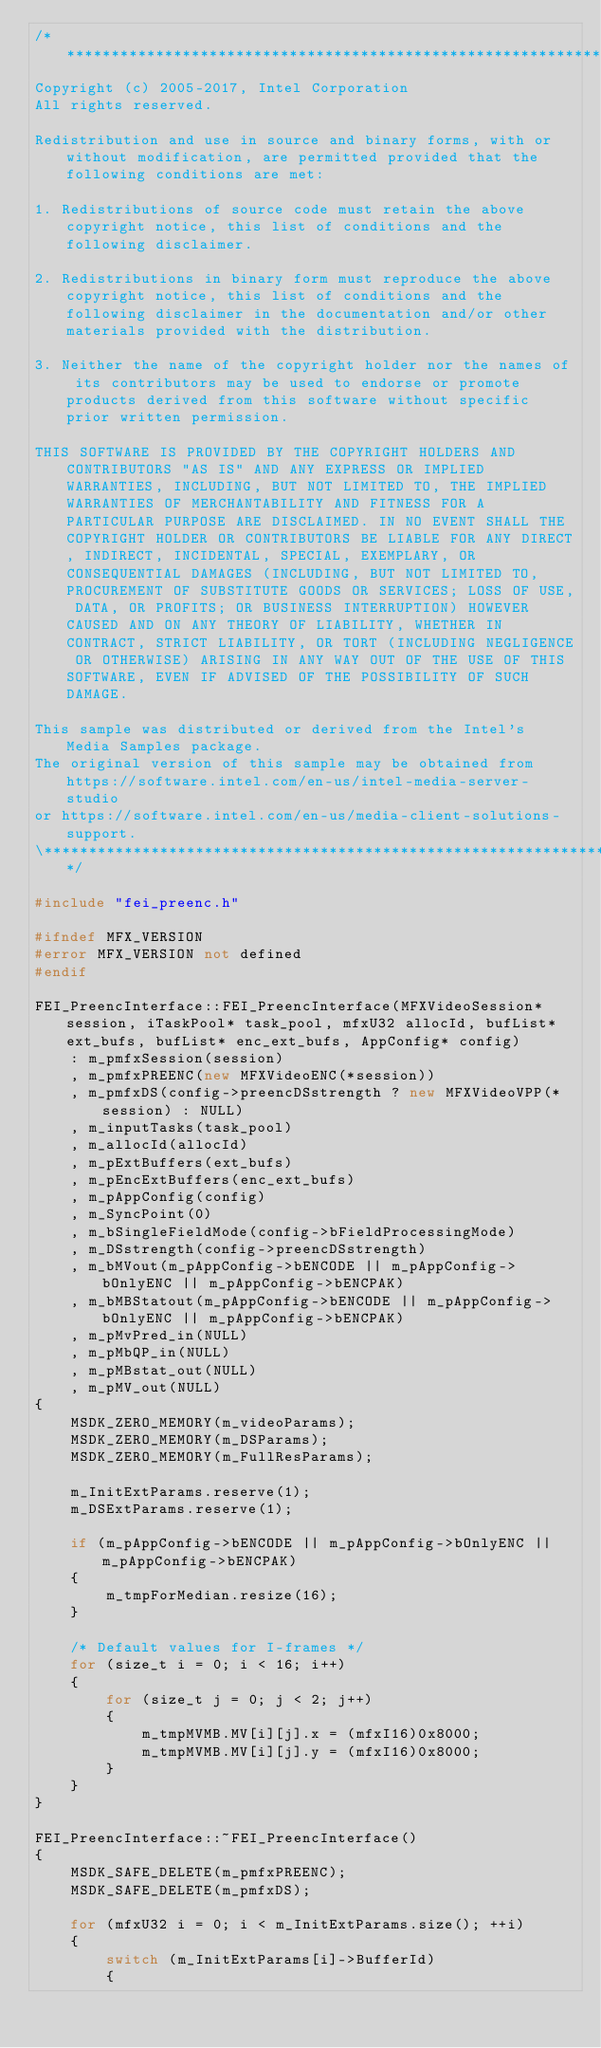<code> <loc_0><loc_0><loc_500><loc_500><_C++_>/******************************************************************************\
Copyright (c) 2005-2017, Intel Corporation
All rights reserved.

Redistribution and use in source and binary forms, with or without modification, are permitted provided that the following conditions are met:

1. Redistributions of source code must retain the above copyright notice, this list of conditions and the following disclaimer.

2. Redistributions in binary form must reproduce the above copyright notice, this list of conditions and the following disclaimer in the documentation and/or other materials provided with the distribution.

3. Neither the name of the copyright holder nor the names of its contributors may be used to endorse or promote products derived from this software without specific prior written permission.

THIS SOFTWARE IS PROVIDED BY THE COPYRIGHT HOLDERS AND CONTRIBUTORS "AS IS" AND ANY EXPRESS OR IMPLIED WARRANTIES, INCLUDING, BUT NOT LIMITED TO, THE IMPLIED WARRANTIES OF MERCHANTABILITY AND FITNESS FOR A PARTICULAR PURPOSE ARE DISCLAIMED. IN NO EVENT SHALL THE COPYRIGHT HOLDER OR CONTRIBUTORS BE LIABLE FOR ANY DIRECT, INDIRECT, INCIDENTAL, SPECIAL, EXEMPLARY, OR CONSEQUENTIAL DAMAGES (INCLUDING, BUT NOT LIMITED TO, PROCUREMENT OF SUBSTITUTE GOODS OR SERVICES; LOSS OF USE, DATA, OR PROFITS; OR BUSINESS INTERRUPTION) HOWEVER CAUSED AND ON ANY THEORY OF LIABILITY, WHETHER IN CONTRACT, STRICT LIABILITY, OR TORT (INCLUDING NEGLIGENCE OR OTHERWISE) ARISING IN ANY WAY OUT OF THE USE OF THIS SOFTWARE, EVEN IF ADVISED OF THE POSSIBILITY OF SUCH DAMAGE.

This sample was distributed or derived from the Intel's Media Samples package.
The original version of this sample may be obtained from https://software.intel.com/en-us/intel-media-server-studio
or https://software.intel.com/en-us/media-client-solutions-support.
\**********************************************************************************/

#include "fei_preenc.h"

#ifndef MFX_VERSION
#error MFX_VERSION not defined
#endif

FEI_PreencInterface::FEI_PreencInterface(MFXVideoSession* session, iTaskPool* task_pool, mfxU32 allocId, bufList* ext_bufs, bufList* enc_ext_bufs, AppConfig* config)
    : m_pmfxSession(session)
    , m_pmfxPREENC(new MFXVideoENC(*session))
    , m_pmfxDS(config->preencDSstrength ? new MFXVideoVPP(*session) : NULL)
    , m_inputTasks(task_pool)
    , m_allocId(allocId)
    , m_pExtBuffers(ext_bufs)
    , m_pEncExtBuffers(enc_ext_bufs)
    , m_pAppConfig(config)
    , m_SyncPoint(0)
    , m_bSingleFieldMode(config->bFieldProcessingMode)
    , m_DSstrength(config->preencDSstrength)
    , m_bMVout(m_pAppConfig->bENCODE || m_pAppConfig->bOnlyENC || m_pAppConfig->bENCPAK)
    , m_bMBStatout(m_pAppConfig->bENCODE || m_pAppConfig->bOnlyENC || m_pAppConfig->bENCPAK)
    , m_pMvPred_in(NULL)
    , m_pMbQP_in(NULL)
    , m_pMBstat_out(NULL)
    , m_pMV_out(NULL)
{
    MSDK_ZERO_MEMORY(m_videoParams);
    MSDK_ZERO_MEMORY(m_DSParams);
    MSDK_ZERO_MEMORY(m_FullResParams);

    m_InitExtParams.reserve(1);
    m_DSExtParams.reserve(1);

    if (m_pAppConfig->bENCODE || m_pAppConfig->bOnlyENC || m_pAppConfig->bENCPAK)
    {
        m_tmpForMedian.resize(16);
    }

    /* Default values for I-frames */
    for (size_t i = 0; i < 16; i++)
    {
        for (size_t j = 0; j < 2; j++)
        {
            m_tmpMVMB.MV[i][j].x = (mfxI16)0x8000;
            m_tmpMVMB.MV[i][j].y = (mfxI16)0x8000;
        }
    }
}

FEI_PreencInterface::~FEI_PreencInterface()
{
    MSDK_SAFE_DELETE(m_pmfxPREENC);
    MSDK_SAFE_DELETE(m_pmfxDS);

    for (mfxU32 i = 0; i < m_InitExtParams.size(); ++i)
    {
        switch (m_InitExtParams[i]->BufferId)
        {</code> 